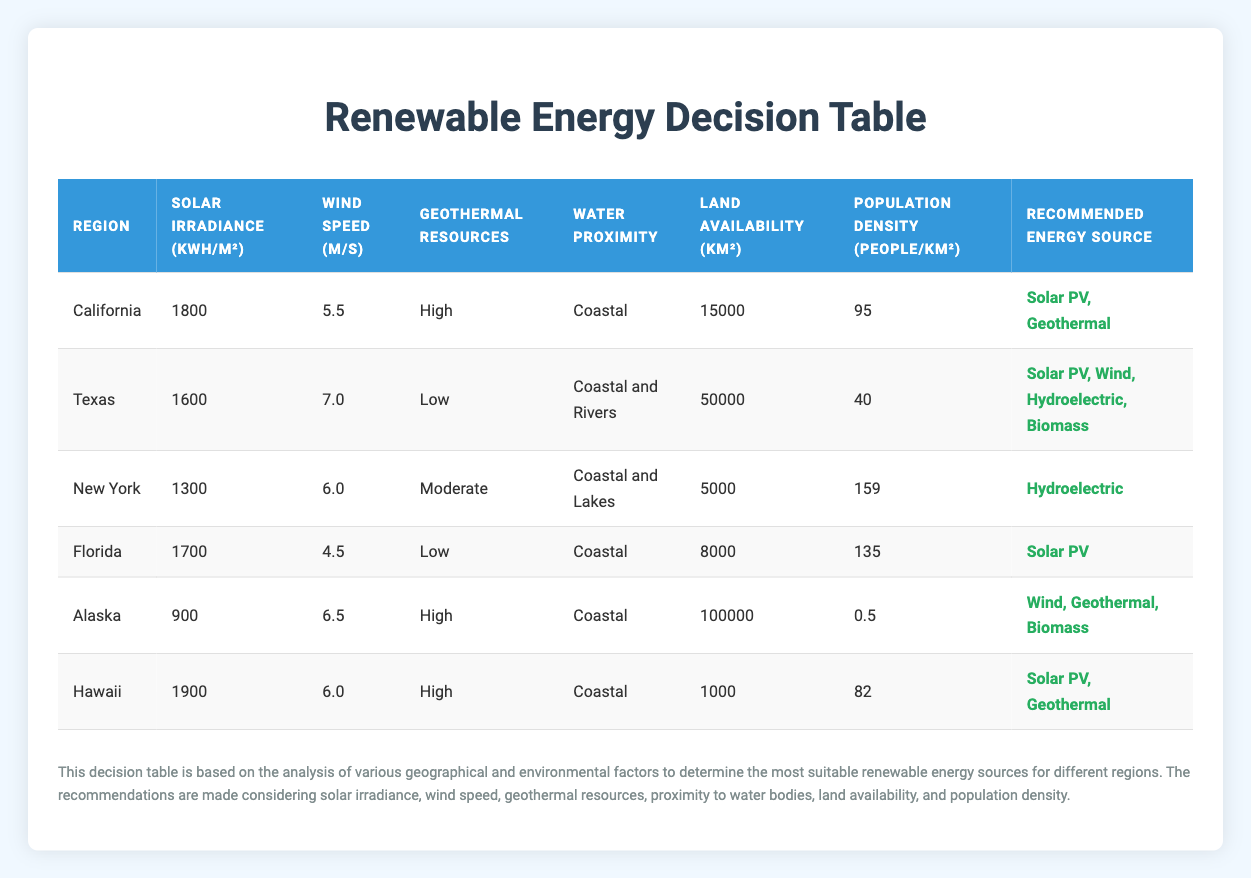What is the average solar irradiance for the regions listed? To calculate the average solar irradiance, we sum the values for solar irradiance from all regions and then divide by the number of regions. The total is (1800 + 1600 + 1300 + 1700 + 900 + 1900) = 10200 kWh/m². There are 6 regions, so the average is 10200 / 6 = 1700 kWh/m².
Answer: 1700 kWh/m² Which region has the highest wind speed? By comparing the wind speed values across the regions, we find the maximum value. The highest wind speed is 7.0 m/s, which is recorded in Texas.
Answer: Texas Does California have low geothermal resources? Looking at the geothermal resources in California, which is categorized as "High," we conclude that the statement is false.
Answer: No Which two renewable energy sources are recommended for Alaska? The recommendations for Alaska are identified by its conditions in the decision rules. Based on the table, Alaska's recommended sources are Wind, Geothermal, and Biomass, but the initial two mentioned in the question are Wind and Geothermal.
Answer: Wind, Geothermal What is the total land availability for all the regions combined? To find the total land availability, we sum the land availability values from all regions: 15000 + 50000 + 5000 + 8000 + 100000 + 1000 = 180000 km².
Answer: 180000 km² How many regions are suitable for Biomass? We assess each region against the decision rules for Biomass, which requires land availability of at least 20000 km² and a population density of 100 or less. The regions that fit this criteria are Texas and Alaska. Thus, there are 2 suitable regions.
Answer: 2 Is Florida recommended for Wind energy? Checking Florida's wind speed and land availability, we see that the wind speed is 4.5 m/s, which does not meet the minimum requirement of 6.0 m/s, thereby leading to the conclusion that Florida is not recommended for Wind energy.
Answer: No What is the difference in population density between New York and Texas? To find the difference, we subtract the population density of Texas (40 people/km²) from that of New York (159 people/km²). The calculation is 159 - 40 = 119 people/km².
Answer: 119 people/km² Which energy source is commonly recommended for coastal regions? From reviewing the recommendations based on the water proximity being "Coastal," we see that Solar PV, Geothermal, and Hydroelectric sources are commonly suggested for regions with coastal proximity. Thus, all these three sources pertain to coastal regions.
Answer: Solar PV, Geothermal, Hydroelectric 